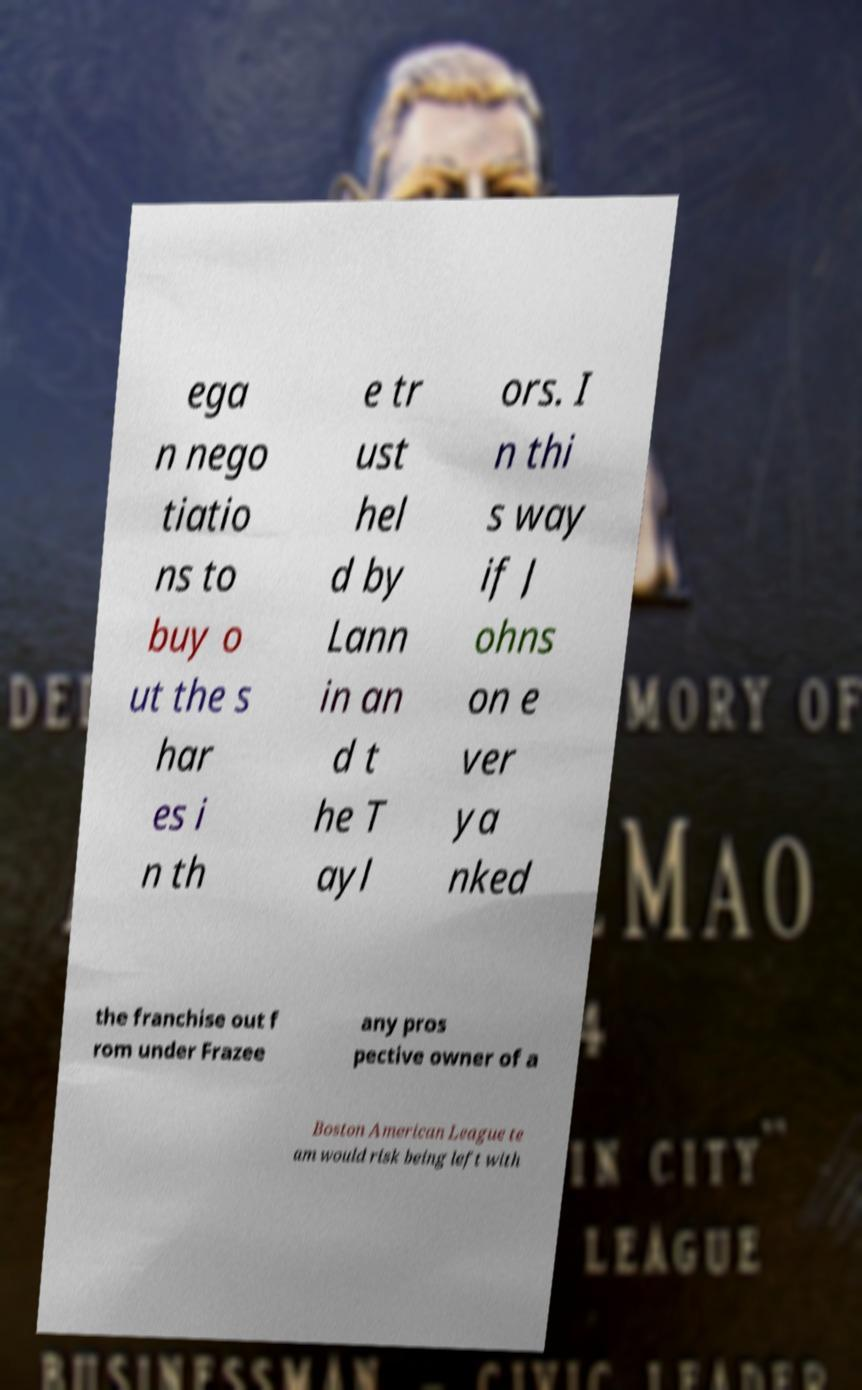There's text embedded in this image that I need extracted. Can you transcribe it verbatim? ega n nego tiatio ns to buy o ut the s har es i n th e tr ust hel d by Lann in an d t he T ayl ors. I n thi s way if J ohns on e ver ya nked the franchise out f rom under Frazee any pros pective owner of a Boston American League te am would risk being left with 